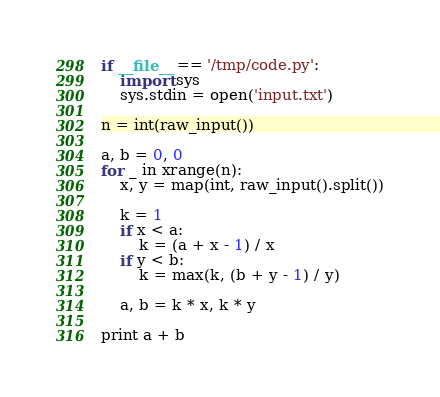Convert code to text. <code><loc_0><loc_0><loc_500><loc_500><_Python_>if __file__ == '/tmp/code.py':
	import sys
	sys.stdin = open('input.txt')

n = int(raw_input())

a, b = 0, 0
for _ in xrange(n):
	x, y = map(int, raw_input().split())

	k = 1
	if x < a:
		k = (a + x - 1) / x
	if y < b:
		k = max(k, (b + y - 1) / y)

	a, b = k * x, k * y

print a + b</code> 